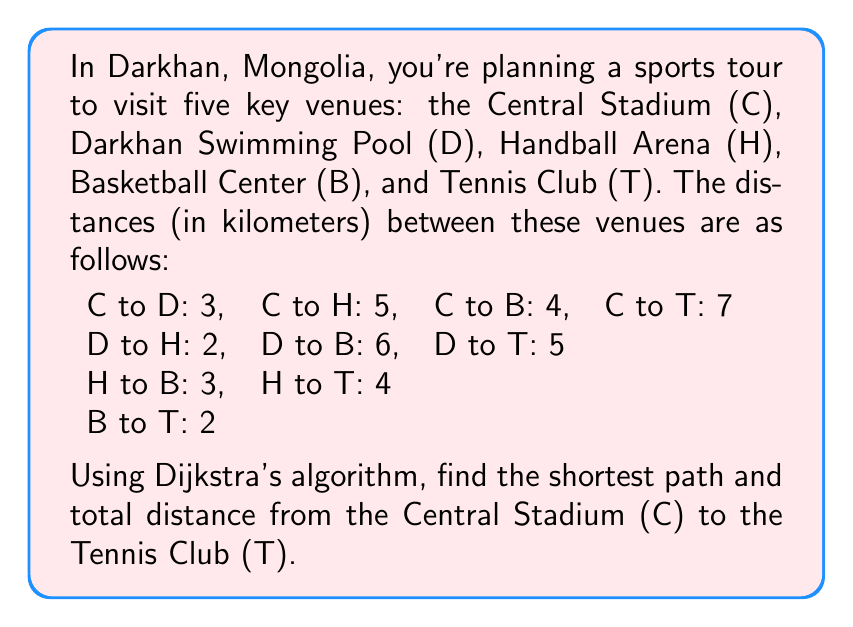Give your solution to this math problem. To solve this problem using Dijkstra's algorithm, we'll follow these steps:

1) Create a graph representation:
   Let's represent the venues as vertices and the distances as weighted edges.

2) Initialize:
   - Set distance to C (start) as 0
   - Set distances to all other vertices as infinity
   - Set all vertices as unvisited

3) For the current vertex (starting with C), consider all unvisited neighbors and calculate their tentative distances.
4) Mark the current vertex as visited once we're done with its neighbors.
5) If the destination vertex (T) has been marked visited, we're done.
6) Otherwise, select the unvisited vertex with the smallest tentative distance and set it as the new current vertex. Go back to step 3.

Let's apply the algorithm:

Step 1: Start at C (distance = 0)
Neighbors of C:
- D: 0 + 3 = 3
- H: 0 + 5 = 5
- B: 0 + 4 = 4
- T: 0 + 7 = 7

Step 2: Mark C as visited. New current vertex: D (smallest tentative distance)
Neighbors of D:
- H: min(5, 3 + 2) = 5
- B: min(4, 3 + 6) = 4
- T: min(7, 3 + 5) = 7

Step 3: Mark D as visited. New current vertex: B
Neighbors of B:
- H: min(5, 4 + 3) = 5
- T: min(7, 4 + 2) = 6

Step 4: Mark B as visited. New current vertex: H
Neighbors of H:
- T: min(6, 5 + 4) = 6

Step 5: Mark H as visited. New current vertex: T

The algorithm terminates as we've reached the destination T.

The shortest path is C → B → T with a total distance of 6 km.
Answer: The shortest path from Central Stadium (C) to Tennis Club (T) is C → B → T, with a total distance of 6 km. 